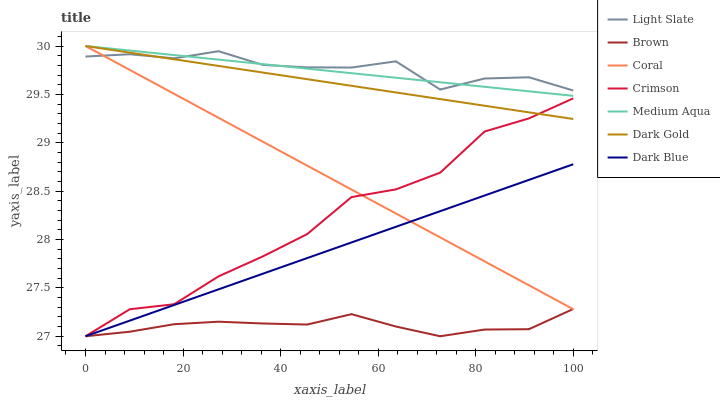Does Brown have the minimum area under the curve?
Answer yes or no. Yes. Does Light Slate have the maximum area under the curve?
Answer yes or no. Yes. Does Dark Gold have the minimum area under the curve?
Answer yes or no. No. Does Dark Gold have the maximum area under the curve?
Answer yes or no. No. Is Dark Blue the smoothest?
Answer yes or no. Yes. Is Crimson the roughest?
Answer yes or no. Yes. Is Dark Gold the smoothest?
Answer yes or no. No. Is Dark Gold the roughest?
Answer yes or no. No. Does Brown have the lowest value?
Answer yes or no. Yes. Does Dark Gold have the lowest value?
Answer yes or no. No. Does Medium Aqua have the highest value?
Answer yes or no. Yes. Does Light Slate have the highest value?
Answer yes or no. No. Is Brown less than Medium Aqua?
Answer yes or no. Yes. Is Light Slate greater than Brown?
Answer yes or no. Yes. Does Brown intersect Coral?
Answer yes or no. Yes. Is Brown less than Coral?
Answer yes or no. No. Is Brown greater than Coral?
Answer yes or no. No. Does Brown intersect Medium Aqua?
Answer yes or no. No. 